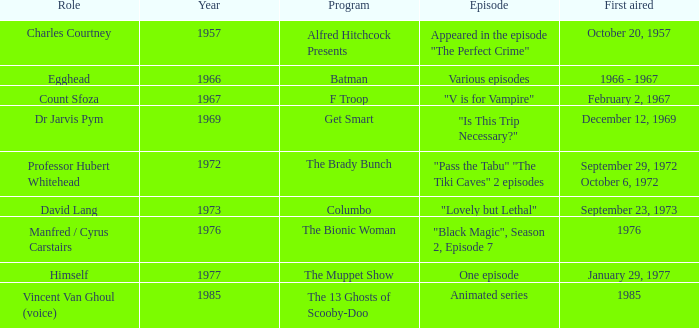What's the first aired date of the Animated Series episode? 1985.0. 